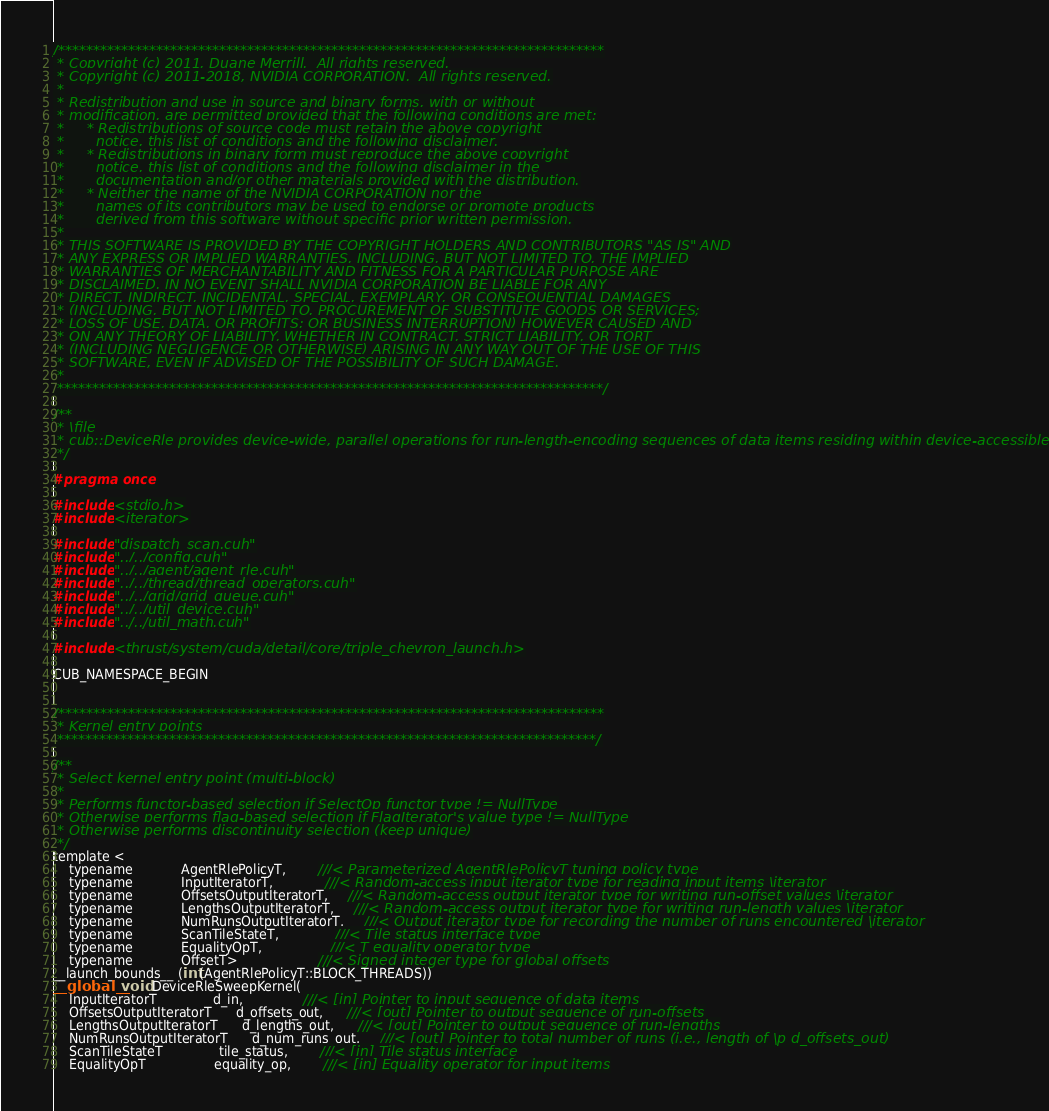<code> <loc_0><loc_0><loc_500><loc_500><_Cuda_>
/******************************************************************************
 * Copyright (c) 2011, Duane Merrill.  All rights reserved.
 * Copyright (c) 2011-2018, NVIDIA CORPORATION.  All rights reserved.
 *
 * Redistribution and use in source and binary forms, with or without
 * modification, are permitted provided that the following conditions are met:
 *     * Redistributions of source code must retain the above copyright
 *       notice, this list of conditions and the following disclaimer.
 *     * Redistributions in binary form must reproduce the above copyright
 *       notice, this list of conditions and the following disclaimer in the
 *       documentation and/or other materials provided with the distribution.
 *     * Neither the name of the NVIDIA CORPORATION nor the
 *       names of its contributors may be used to endorse or promote products
 *       derived from this software without specific prior written permission.
 *
 * THIS SOFTWARE IS PROVIDED BY THE COPYRIGHT HOLDERS AND CONTRIBUTORS "AS IS" AND
 * ANY EXPRESS OR IMPLIED WARRANTIES, INCLUDING, BUT NOT LIMITED TO, THE IMPLIED
 * WARRANTIES OF MERCHANTABILITY AND FITNESS FOR A PARTICULAR PURPOSE ARE
 * DISCLAIMED. IN NO EVENT SHALL NVIDIA CORPORATION BE LIABLE FOR ANY
 * DIRECT, INDIRECT, INCIDENTAL, SPECIAL, EXEMPLARY, OR CONSEQUENTIAL DAMAGES
 * (INCLUDING, BUT NOT LIMITED TO, PROCUREMENT OF SUBSTITUTE GOODS OR SERVICES;
 * LOSS OF USE, DATA, OR PROFITS; OR BUSINESS INTERRUPTION) HOWEVER CAUSED AND
 * ON ANY THEORY OF LIABILITY, WHETHER IN CONTRACT, STRICT LIABILITY, OR TORT
 * (INCLUDING NEGLIGENCE OR OTHERWISE) ARISING IN ANY WAY OUT OF THE USE OF THIS
 * SOFTWARE, EVEN IF ADVISED OF THE POSSIBILITY OF SUCH DAMAGE.
 *
 ******************************************************************************/

/**
 * \file
 * cub::DeviceRle provides device-wide, parallel operations for run-length-encoding sequences of data items residing within device-accessible memory.
 */

#pragma once

#include <stdio.h>
#include <iterator>

#include "dispatch_scan.cuh"
#include "../../config.cuh"
#include "../../agent/agent_rle.cuh"
#include "../../thread/thread_operators.cuh"
#include "../../grid/grid_queue.cuh"
#include "../../util_device.cuh"
#include "../../util_math.cuh"

#include <thrust/system/cuda/detail/core/triple_chevron_launch.h>

CUB_NAMESPACE_BEGIN


/******************************************************************************
 * Kernel entry points
 *****************************************************************************/

/**
 * Select kernel entry point (multi-block)
 *
 * Performs functor-based selection if SelectOp functor type != NullType
 * Otherwise performs flag-based selection if FlagIterator's value type != NullType
 * Otherwise performs discontinuity selection (keep unique)
 */
template <
    typename            AgentRlePolicyT,        ///< Parameterized AgentRlePolicyT tuning policy type
    typename            InputIteratorT,             ///< Random-access input iterator type for reading input items \iterator
    typename            OffsetsOutputIteratorT,     ///< Random-access output iterator type for writing run-offset values \iterator
    typename            LengthsOutputIteratorT,     ///< Random-access output iterator type for writing run-length values \iterator
    typename            NumRunsOutputIteratorT,     ///< Output iterator type for recording the number of runs encountered \iterator
    typename            ScanTileStateT,              ///< Tile status interface type
    typename            EqualityOpT,                 ///< T equality operator type
    typename            OffsetT>                    ///< Signed integer type for global offsets
__launch_bounds__ (int(AgentRlePolicyT::BLOCK_THREADS))
__global__ void DeviceRleSweepKernel(
    InputIteratorT              d_in,               ///< [in] Pointer to input sequence of data items
    OffsetsOutputIteratorT      d_offsets_out,      ///< [out] Pointer to output sequence of run-offsets
    LengthsOutputIteratorT      d_lengths_out,      ///< [out] Pointer to output sequence of run-lengths
    NumRunsOutputIteratorT      d_num_runs_out,     ///< [out] Pointer to total number of runs (i.e., length of \p d_offsets_out)
    ScanTileStateT              tile_status,        ///< [in] Tile status interface
    EqualityOpT                 equality_op,        ///< [in] Equality operator for input items</code> 